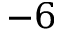Convert formula to latex. <formula><loc_0><loc_0><loc_500><loc_500>{ - 6 }</formula> 